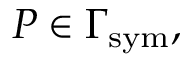Convert formula to latex. <formula><loc_0><loc_0><loc_500><loc_500>P \in \Gamma _ { s y m } ,</formula> 